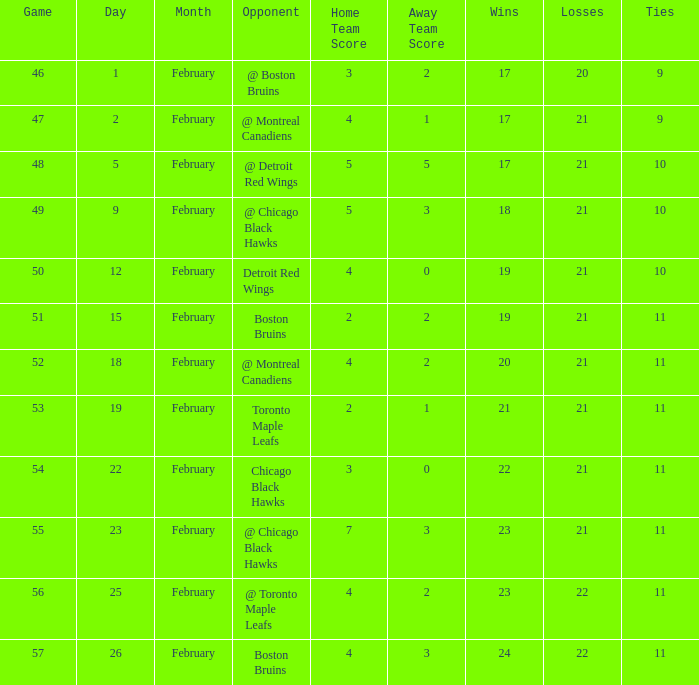What was the score of the game 57 after February 23? 4 - 3. 